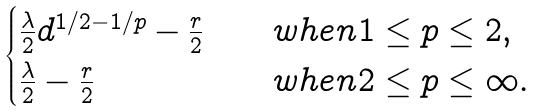Convert formula to latex. <formula><loc_0><loc_0><loc_500><loc_500>\begin{cases} \frac { \lambda } { 2 } d ^ { 1 / 2 - 1 / p } - \frac { r } { 2 } & \quad w h e n 1 \leq p \leq 2 , \\ \frac { \lambda } { 2 } - \frac { r } { 2 } & \quad w h e n 2 \leq p \leq \infty . \end{cases}</formula> 